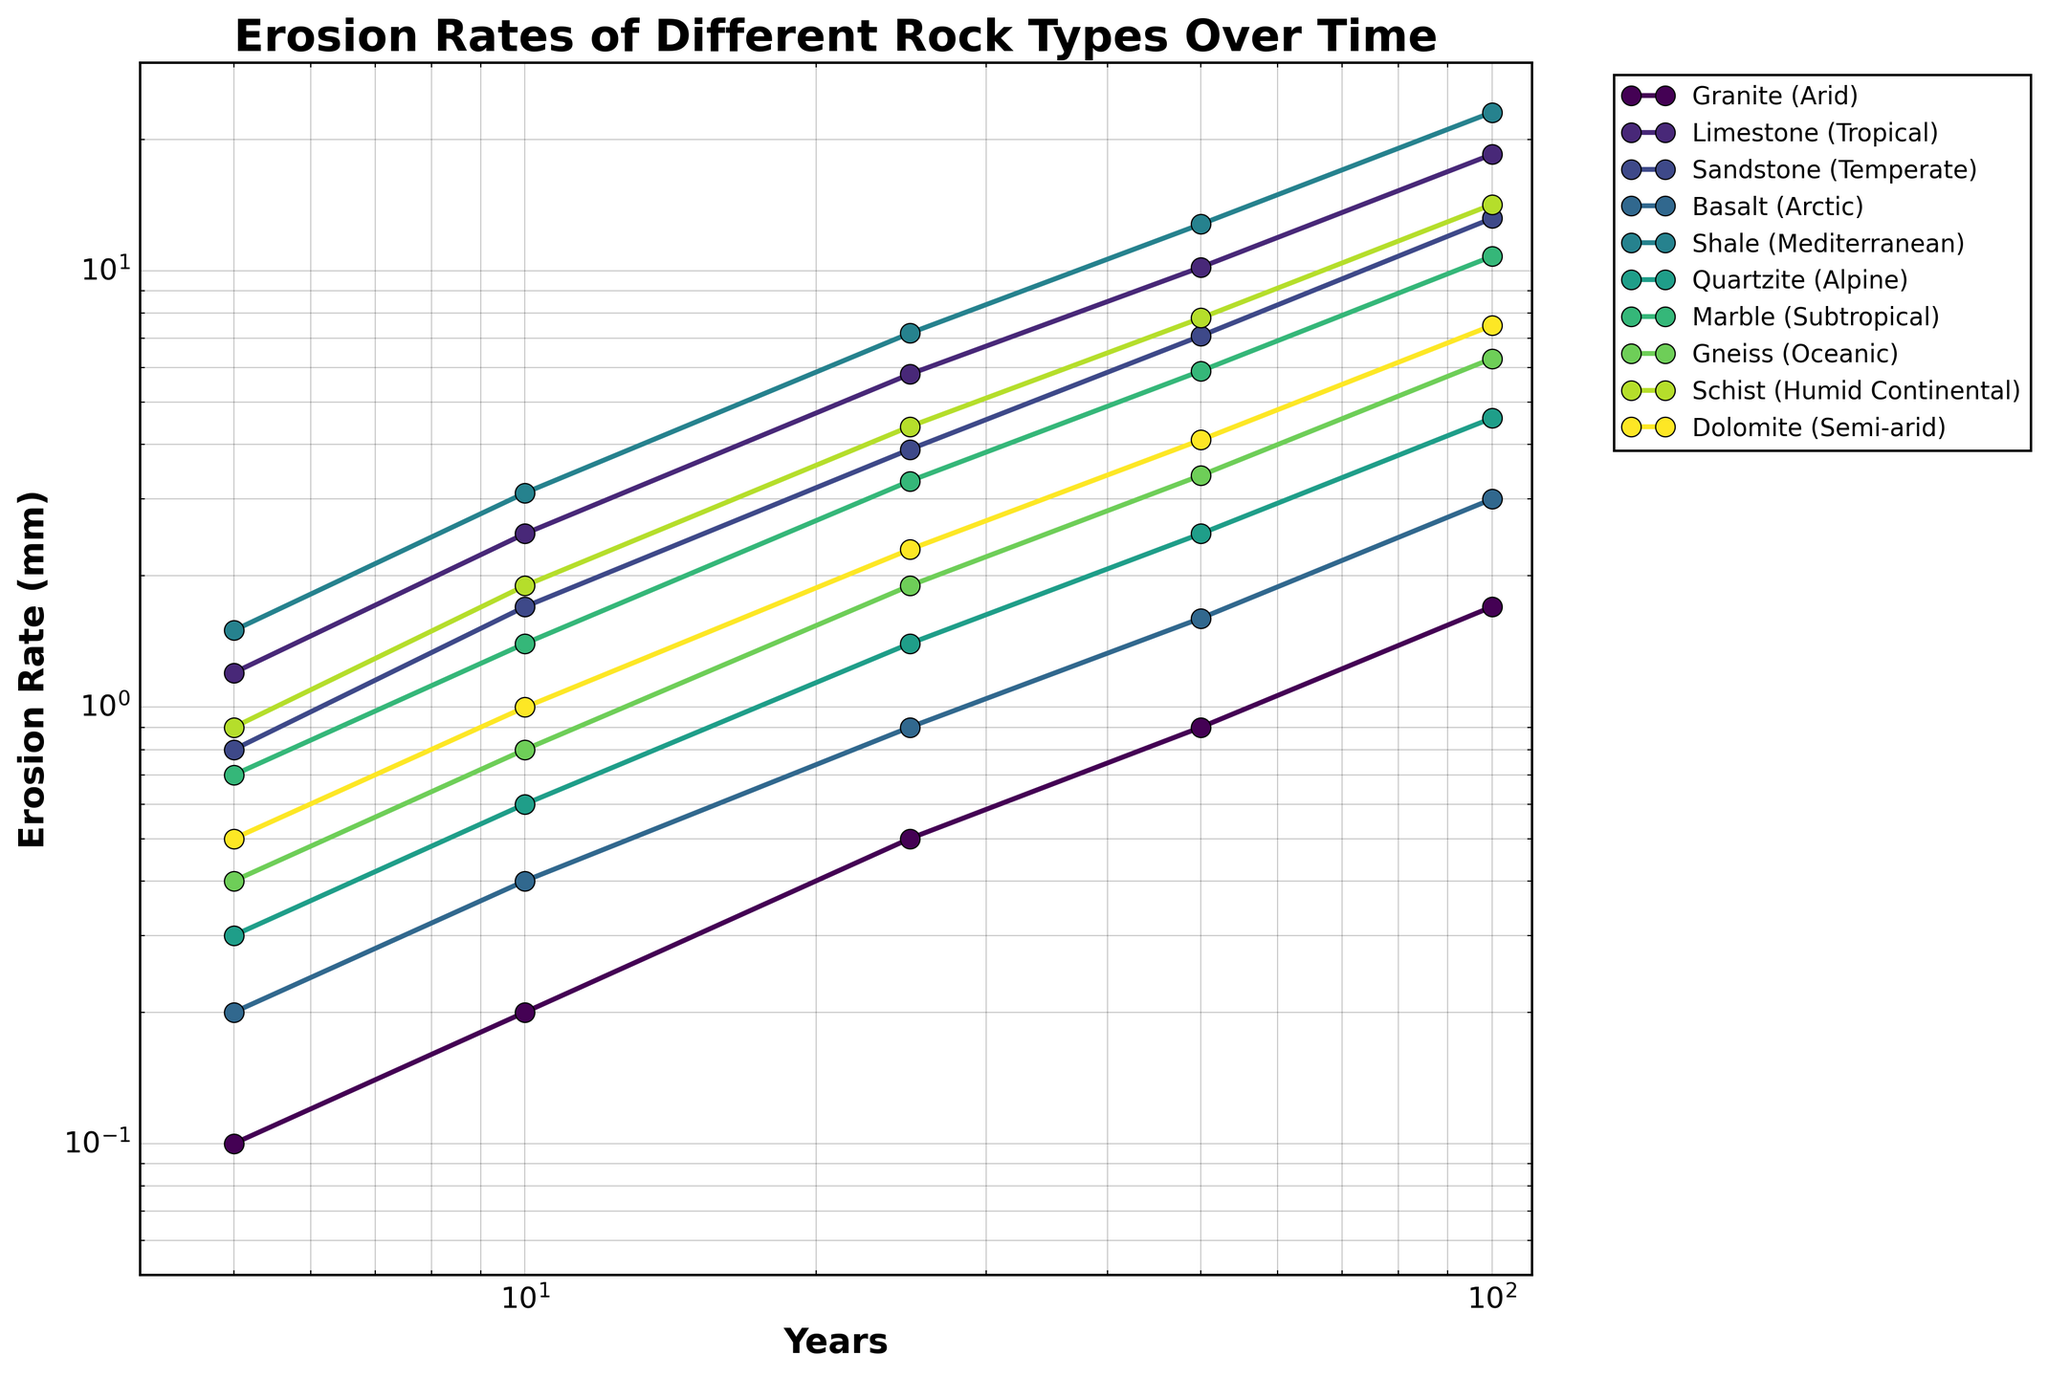Which rock type has the highest erosion rate after 100 years? Identify the lines on the plot labeled with different rock types and find the one that extends the furthest up the y-axis at the 100-year mark.
Answer: Shale How does the erosion rate of Granite in an Arid climate compare to Basalt in an Arctic climate after 5 years? Locate the two lines representing Granite in an Arid climate and Basalt in an Arctic climate and compare their y-values at the 5-year mark.
Answer: Granite is higher Which rock type in a Mediterranean climate has a higher erosion rate, and what is the rate? Find the line with the label "Shale (Mediterranean)" and read its erosion rate at the maximum x-value (100 years) on the plot.
Answer: Shale, 23.1 mm What's the difference in erosion rates between Limestone in a Tropical climate and Marble in a Subtropical climate after 50 years? Locate the lines for Limestone in a Tropical climate and Marble in a Subtropical climate, and find the y-values at the 50-year mark. The difference is calculated by subtracting the erosion rate of Marble from that of Limestone.
Answer: 10.2 - 5.9 = 4.3 mm What is the average erosion rate of Quartzite in an Alpine climate over all the time intervals? Locate the line for Quartzite in an Alpine climate and average its y-values at all the time intervals (5, 10, 25, 50, 100 years). Add the values and divide by the number of intervals (5) for the average.
Answer: (0.3 + 0.6 + 1.4 + 2.5 + 4.6) / 5 = 1.88 mm Which rock type shows the steepest increase in erosion rates between 25 and 50 years? Observe the slopes of the lines between the 25-year and 50-year marks and identify the one with the steepest upward slope.
Answer: Shale Compare the erosion rates of Sandstone in a Temperate climate and Schist in a Humid Continental climate at 25 years. Which is higher? Locate the erosion rates of Sandstone and Schist at the 25-year mark and compare the values to determine which is higher.
Answer: Schist is higher What is the erosion rate of Gneiss in an Oceanic climate at the 10-year mark? Find the line representing Gneiss in an Oceanic climate and read the y-value at the 10-year mark on the x-axis.
Answer: 0.8 mm Which rock type experiences the least erosion in the initial 5-year period, and what is that erosion rate? Identify the rock type with the lowest y-value at the 5-year mark by examining the start of each line on the plot.
Answer: Granite, 0.1 mm 